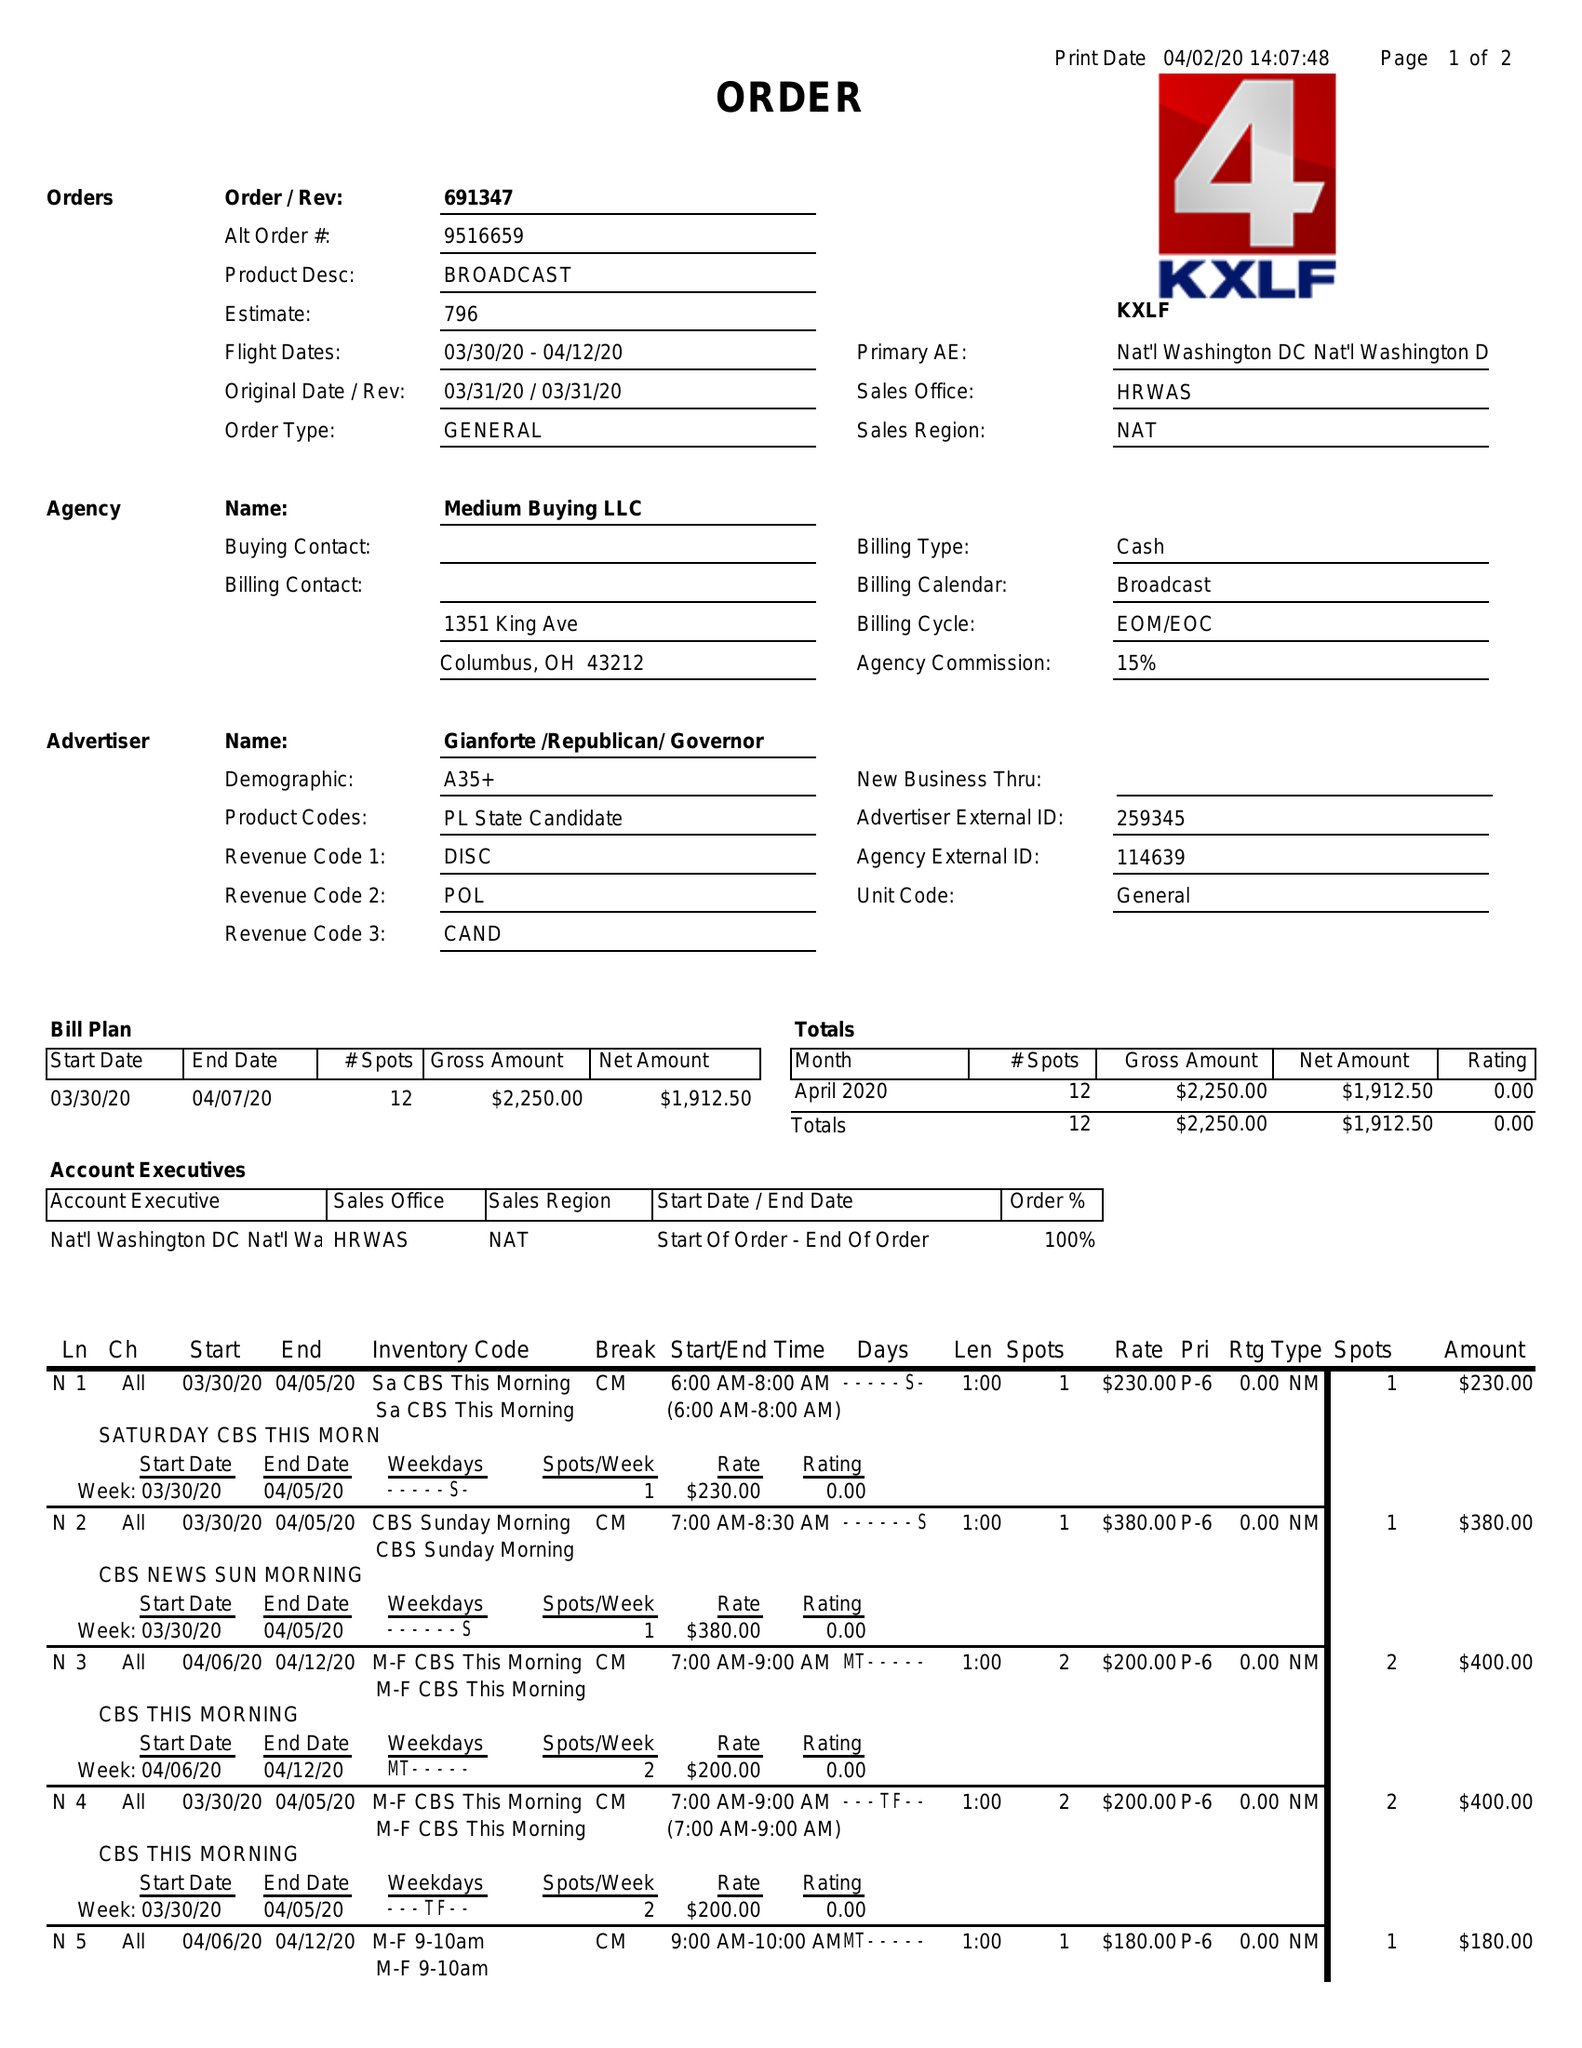What is the value for the gross_amount?
Answer the question using a single word or phrase. 2250.00 